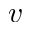Convert formula to latex. <formula><loc_0><loc_0><loc_500><loc_500>v</formula> 